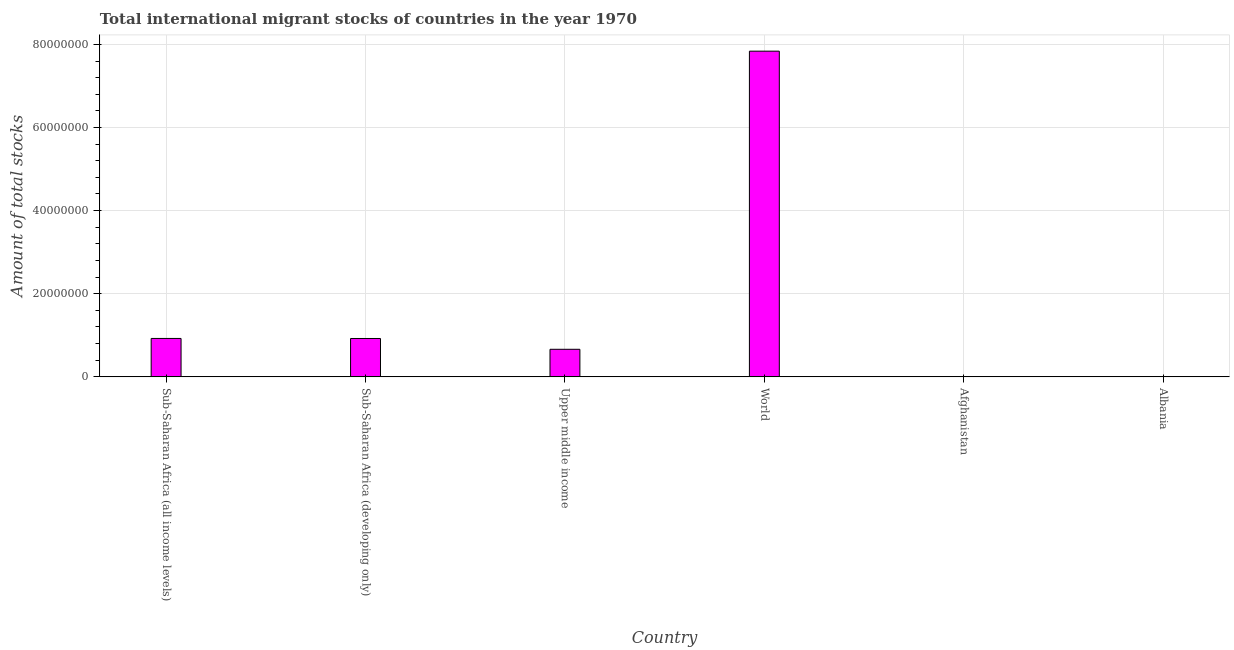Does the graph contain any zero values?
Ensure brevity in your answer.  No. What is the title of the graph?
Keep it short and to the point. Total international migrant stocks of countries in the year 1970. What is the label or title of the X-axis?
Offer a terse response. Country. What is the label or title of the Y-axis?
Offer a terse response. Amount of total stocks. What is the total number of international migrant stock in Albania?
Offer a terse response. 5.40e+04. Across all countries, what is the maximum total number of international migrant stock?
Ensure brevity in your answer.  7.84e+07. Across all countries, what is the minimum total number of international migrant stock?
Provide a succinct answer. 5.31e+04. In which country was the total number of international migrant stock maximum?
Your response must be concise. World. In which country was the total number of international migrant stock minimum?
Give a very brief answer. Afghanistan. What is the sum of the total number of international migrant stock?
Give a very brief answer. 1.04e+08. What is the difference between the total number of international migrant stock in Upper middle income and World?
Ensure brevity in your answer.  -7.17e+07. What is the average total number of international migrant stock per country?
Provide a short and direct response. 1.73e+07. What is the median total number of international migrant stock?
Keep it short and to the point. 7.94e+06. In how many countries, is the total number of international migrant stock greater than 4000000 ?
Give a very brief answer. 4. What is the ratio of the total number of international migrant stock in Sub-Saharan Africa (all income levels) to that in Upper middle income?
Provide a succinct answer. 1.39. Is the difference between the total number of international migrant stock in Sub-Saharan Africa (all income levels) and Upper middle income greater than the difference between any two countries?
Your response must be concise. No. What is the difference between the highest and the second highest total number of international migrant stock?
Offer a very short reply. 6.91e+07. What is the difference between the highest and the lowest total number of international migrant stock?
Your response must be concise. 7.83e+07. In how many countries, is the total number of international migrant stock greater than the average total number of international migrant stock taken over all countries?
Your response must be concise. 1. How many countries are there in the graph?
Ensure brevity in your answer.  6. What is the Amount of total stocks of Sub-Saharan Africa (all income levels)?
Keep it short and to the point. 9.25e+06. What is the Amount of total stocks in Sub-Saharan Africa (developing only)?
Offer a terse response. 9.23e+06. What is the Amount of total stocks of Upper middle income?
Your answer should be very brief. 6.64e+06. What is the Amount of total stocks of World?
Your response must be concise. 7.84e+07. What is the Amount of total stocks of Afghanistan?
Ensure brevity in your answer.  5.31e+04. What is the Amount of total stocks of Albania?
Provide a succinct answer. 5.40e+04. What is the difference between the Amount of total stocks in Sub-Saharan Africa (all income levels) and Sub-Saharan Africa (developing only)?
Offer a very short reply. 1.26e+04. What is the difference between the Amount of total stocks in Sub-Saharan Africa (all income levels) and Upper middle income?
Give a very brief answer. 2.61e+06. What is the difference between the Amount of total stocks in Sub-Saharan Africa (all income levels) and World?
Make the answer very short. -6.91e+07. What is the difference between the Amount of total stocks in Sub-Saharan Africa (all income levels) and Afghanistan?
Your answer should be very brief. 9.19e+06. What is the difference between the Amount of total stocks in Sub-Saharan Africa (all income levels) and Albania?
Give a very brief answer. 9.19e+06. What is the difference between the Amount of total stocks in Sub-Saharan Africa (developing only) and Upper middle income?
Provide a short and direct response. 2.60e+06. What is the difference between the Amount of total stocks in Sub-Saharan Africa (developing only) and World?
Your answer should be compact. -6.91e+07. What is the difference between the Amount of total stocks in Sub-Saharan Africa (developing only) and Afghanistan?
Offer a terse response. 9.18e+06. What is the difference between the Amount of total stocks in Sub-Saharan Africa (developing only) and Albania?
Provide a short and direct response. 9.18e+06. What is the difference between the Amount of total stocks in Upper middle income and World?
Offer a very short reply. -7.17e+07. What is the difference between the Amount of total stocks in Upper middle income and Afghanistan?
Offer a very short reply. 6.58e+06. What is the difference between the Amount of total stocks in Upper middle income and Albania?
Keep it short and to the point. 6.58e+06. What is the difference between the Amount of total stocks in World and Afghanistan?
Give a very brief answer. 7.83e+07. What is the difference between the Amount of total stocks in World and Albania?
Keep it short and to the point. 7.83e+07. What is the difference between the Amount of total stocks in Afghanistan and Albania?
Your answer should be very brief. -994. What is the ratio of the Amount of total stocks in Sub-Saharan Africa (all income levels) to that in Sub-Saharan Africa (developing only)?
Your response must be concise. 1. What is the ratio of the Amount of total stocks in Sub-Saharan Africa (all income levels) to that in Upper middle income?
Your answer should be compact. 1.39. What is the ratio of the Amount of total stocks in Sub-Saharan Africa (all income levels) to that in World?
Your answer should be compact. 0.12. What is the ratio of the Amount of total stocks in Sub-Saharan Africa (all income levels) to that in Afghanistan?
Your response must be concise. 174.3. What is the ratio of the Amount of total stocks in Sub-Saharan Africa (all income levels) to that in Albania?
Provide a succinct answer. 171.09. What is the ratio of the Amount of total stocks in Sub-Saharan Africa (developing only) to that in Upper middle income?
Your answer should be very brief. 1.39. What is the ratio of the Amount of total stocks in Sub-Saharan Africa (developing only) to that in World?
Your answer should be compact. 0.12. What is the ratio of the Amount of total stocks in Sub-Saharan Africa (developing only) to that in Afghanistan?
Your answer should be very brief. 174.06. What is the ratio of the Amount of total stocks in Sub-Saharan Africa (developing only) to that in Albania?
Your answer should be compact. 170.86. What is the ratio of the Amount of total stocks in Upper middle income to that in World?
Offer a very short reply. 0.09. What is the ratio of the Amount of total stocks in Upper middle income to that in Afghanistan?
Provide a succinct answer. 125.11. What is the ratio of the Amount of total stocks in Upper middle income to that in Albania?
Offer a very short reply. 122.8. What is the ratio of the Amount of total stocks in World to that in Afghanistan?
Provide a short and direct response. 1477.22. What is the ratio of the Amount of total stocks in World to that in Albania?
Offer a very short reply. 1450.05. What is the ratio of the Amount of total stocks in Afghanistan to that in Albania?
Make the answer very short. 0.98. 